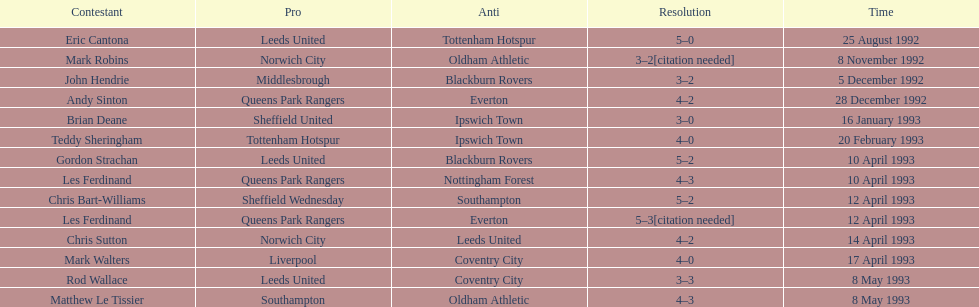Which player had the same result as mark robins? John Hendrie. 